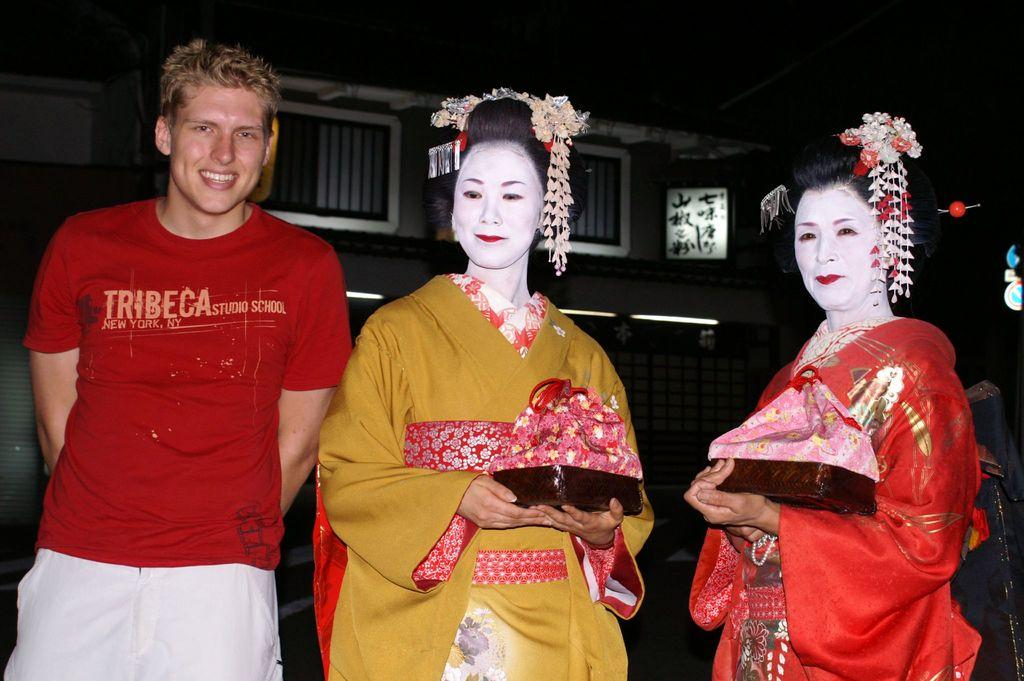Provide a one-sentence caption for the provided image. A man in a red Tribeca shirt stand next to two women dressed in kabuki. 